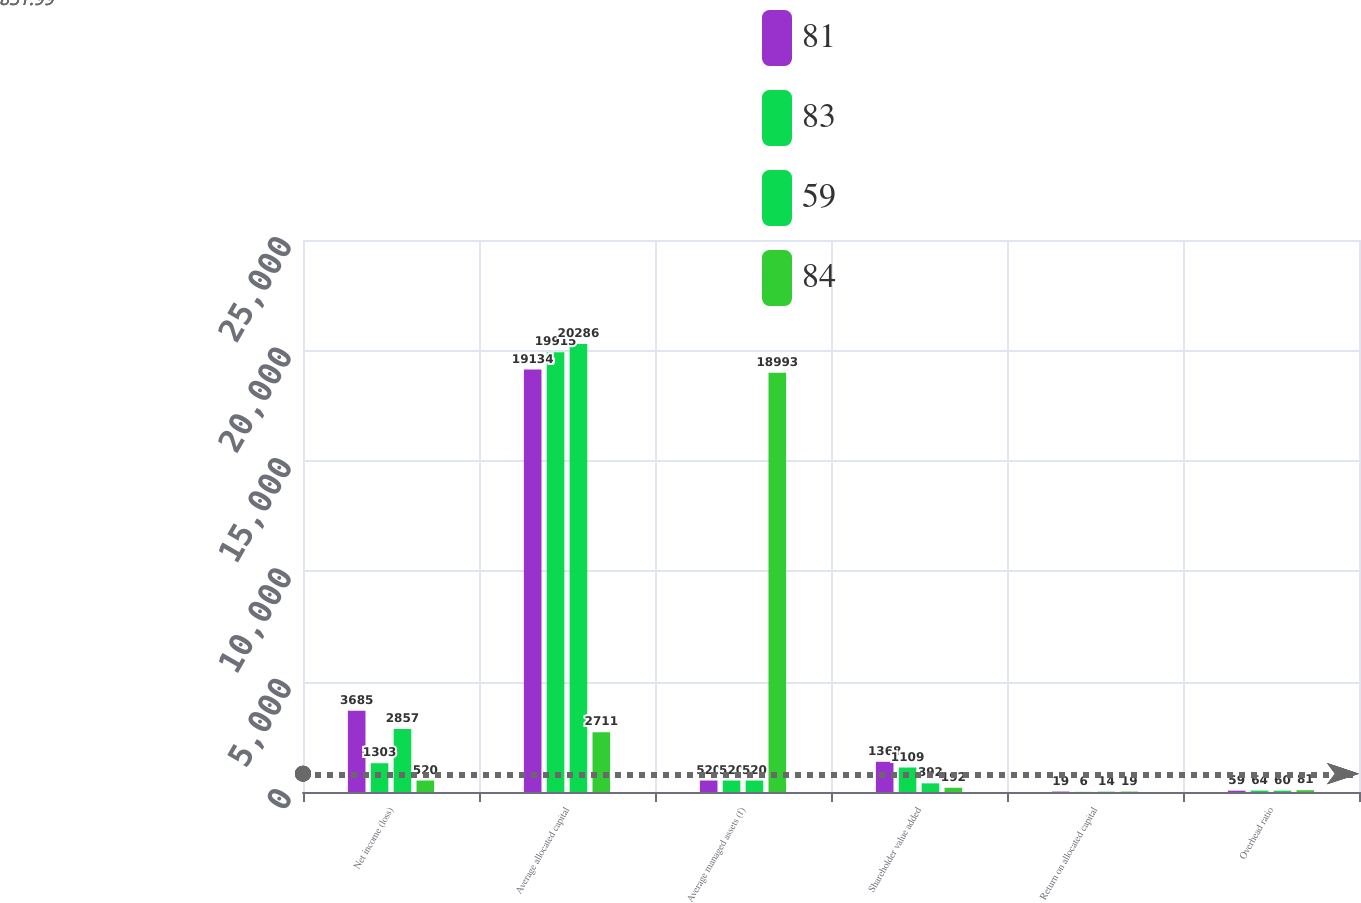Convert chart. <chart><loc_0><loc_0><loc_500><loc_500><stacked_bar_chart><ecel><fcel>Net income (loss)<fcel>Average allocated capital<fcel>Average managed assets (f)<fcel>Shareholder value added<fcel>Return on allocated capital<fcel>Overhead ratio<nl><fcel>81<fcel>3685<fcel>19134<fcel>520<fcel>1368<fcel>19<fcel>59<nl><fcel>83<fcel>1303<fcel>19915<fcel>520<fcel>1109<fcel>6<fcel>64<nl><fcel>59<fcel>2857<fcel>20286<fcel>520<fcel>392<fcel>14<fcel>60<nl><fcel>84<fcel>520<fcel>2711<fcel>18993<fcel>192<fcel>19<fcel>81<nl></chart> 